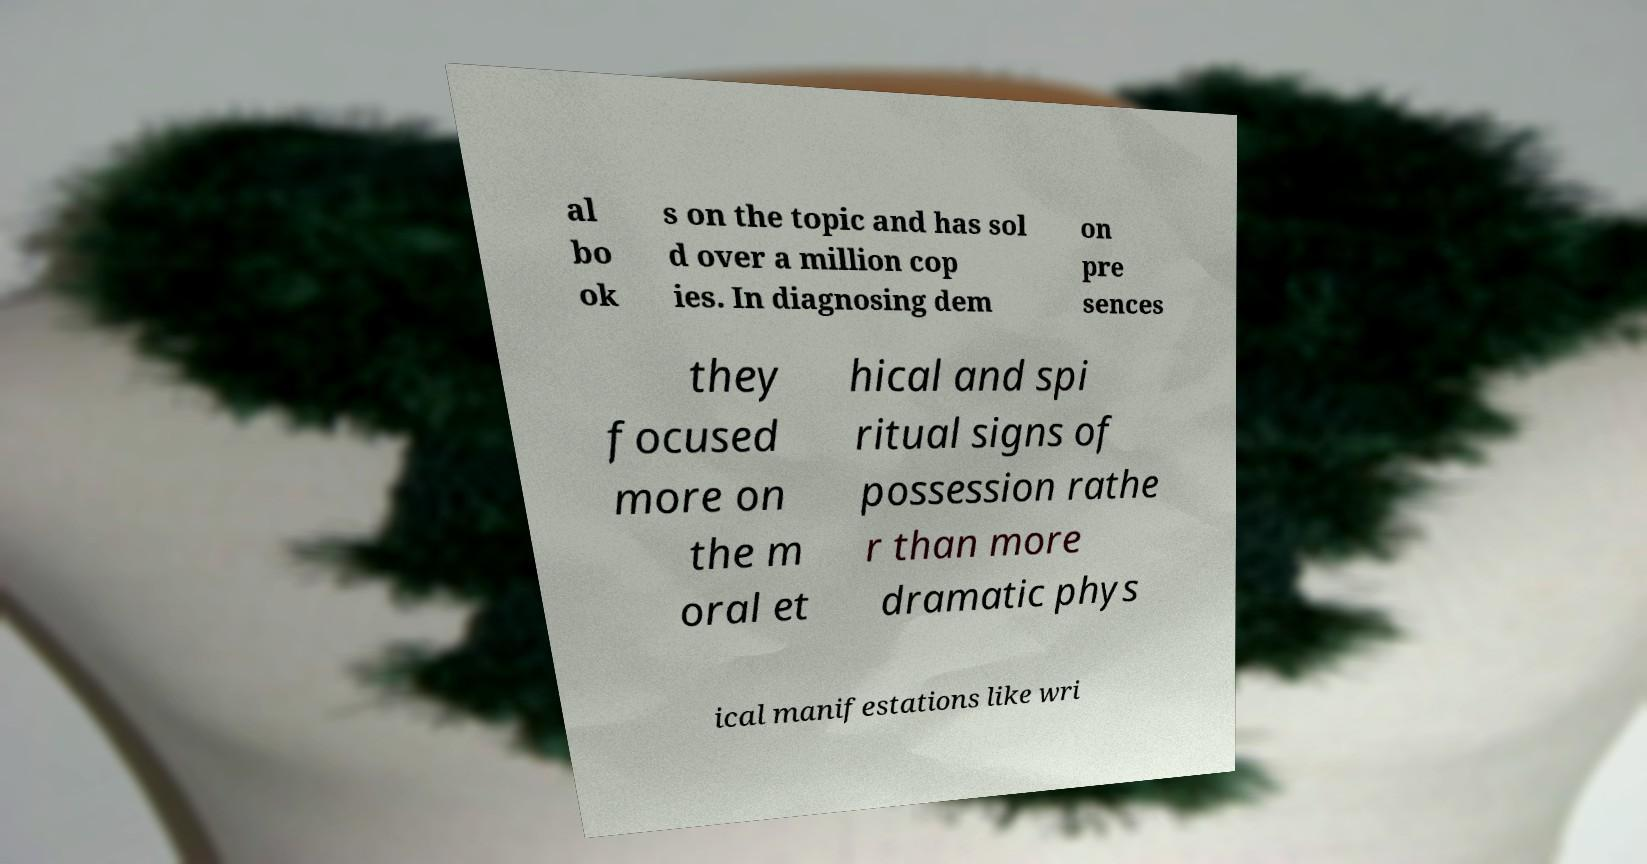Please read and relay the text visible in this image. What does it say? al bo ok s on the topic and has sol d over a million cop ies. In diagnosing dem on pre sences they focused more on the m oral et hical and spi ritual signs of possession rathe r than more dramatic phys ical manifestations like wri 